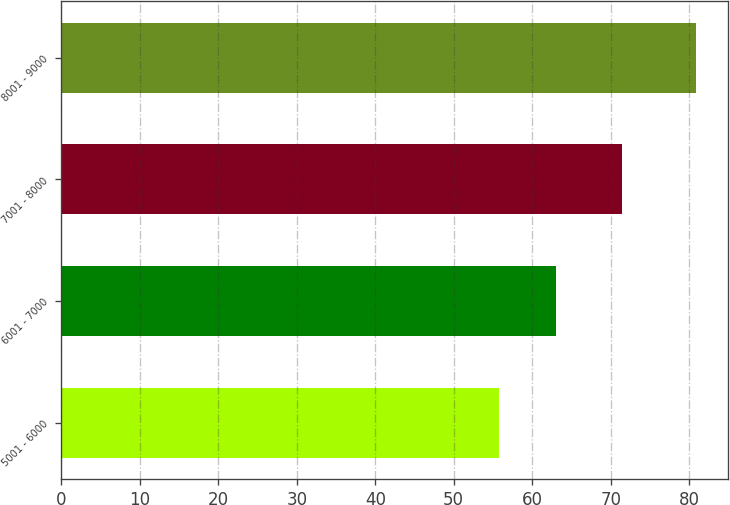<chart> <loc_0><loc_0><loc_500><loc_500><bar_chart><fcel>5001 - 6000<fcel>6001 - 7000<fcel>7001 - 8000<fcel>8001 - 9000<nl><fcel>55.83<fcel>62.98<fcel>71.47<fcel>80.92<nl></chart> 